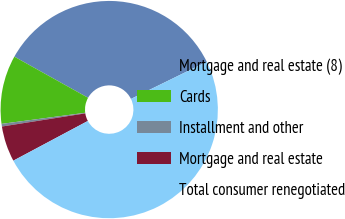Convert chart. <chart><loc_0><loc_0><loc_500><loc_500><pie_chart><fcel>Mortgage and real estate (8)<fcel>Cards<fcel>Installment and other<fcel>Mortgage and real estate<fcel>Total consumer renegotiated<nl><fcel>34.65%<fcel>10.2%<fcel>0.39%<fcel>5.3%<fcel>49.46%<nl></chart> 